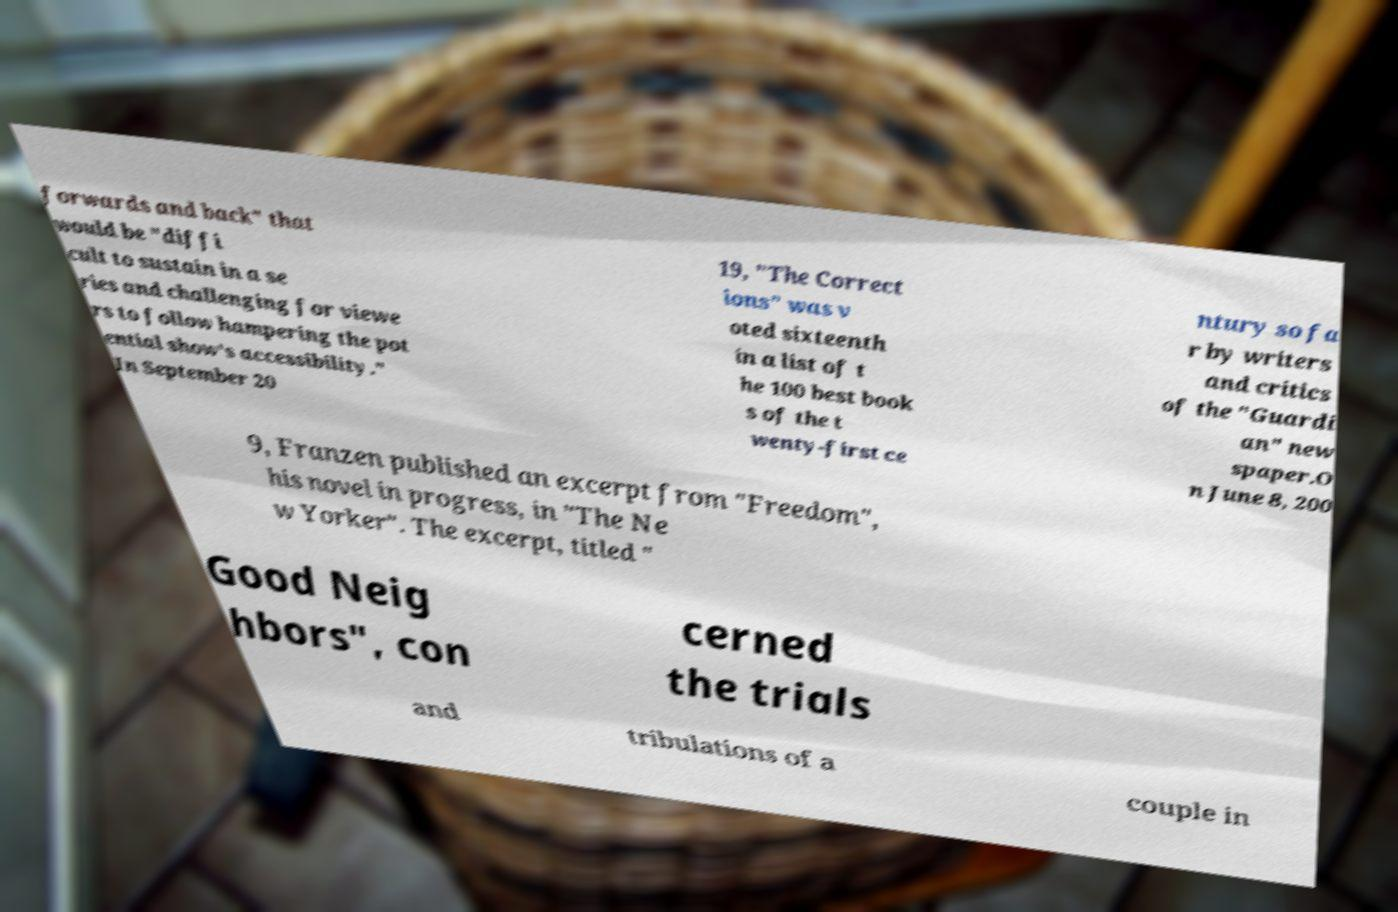Can you read and provide the text displayed in the image?This photo seems to have some interesting text. Can you extract and type it out for me? forwards and back" that would be "diffi cult to sustain in a se ries and challenging for viewe rs to follow hampering the pot ential show's accessibility." In September 20 19, "The Correct ions" was v oted sixteenth in a list of t he 100 best book s of the t wenty-first ce ntury so fa r by writers and critics of the "Guardi an" new spaper.O n June 8, 200 9, Franzen published an excerpt from "Freedom", his novel in progress, in "The Ne w Yorker". The excerpt, titled " Good Neig hbors", con cerned the trials and tribulations of a couple in 